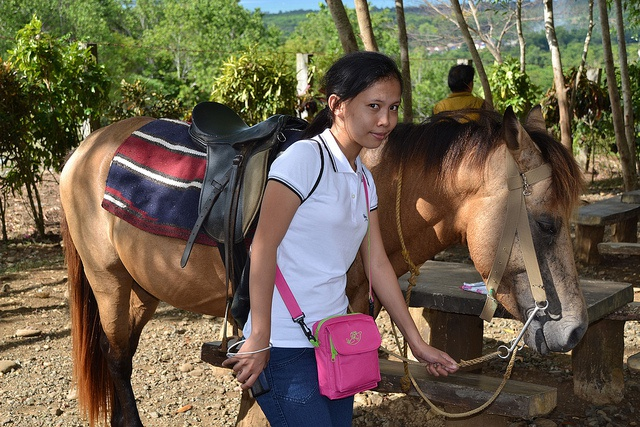Describe the objects in this image and their specific colors. I can see horse in green, black, maroon, and gray tones, people in green, gray, darkgray, black, and lavender tones, bench in green, black, and gray tones, bench in green, black, and gray tones, and handbag in green, purple, and magenta tones in this image. 